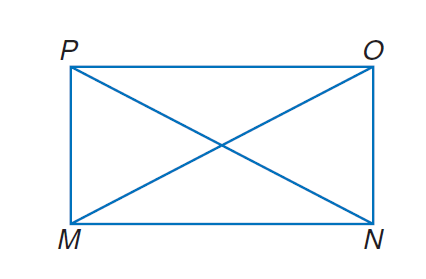Question: Quadrilateral M N O P is a rectangle. If M O = 6 x + 14 and P N = 9 x + 5, find x.
Choices:
A. 3
B. 6
C. 9
D. 12
Answer with the letter. Answer: A 